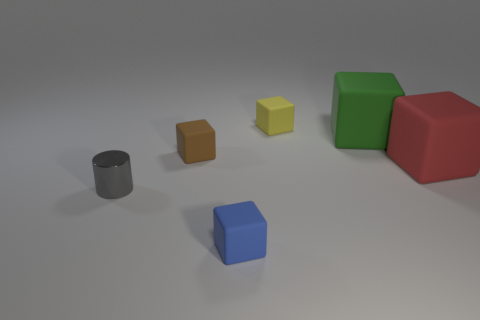Subtract 1 blocks. How many blocks are left? 4 Subtract all brown rubber blocks. How many blocks are left? 4 Subtract all red blocks. How many blocks are left? 4 Subtract all purple cubes. Subtract all gray balls. How many cubes are left? 5 Add 1 tiny brown shiny cylinders. How many objects exist? 7 Subtract all cylinders. How many objects are left? 5 Subtract all yellow balls. Subtract all tiny yellow rubber blocks. How many objects are left? 5 Add 3 gray shiny cylinders. How many gray shiny cylinders are left? 4 Add 1 large cyan rubber cubes. How many large cyan rubber cubes exist? 1 Subtract 1 brown blocks. How many objects are left? 5 